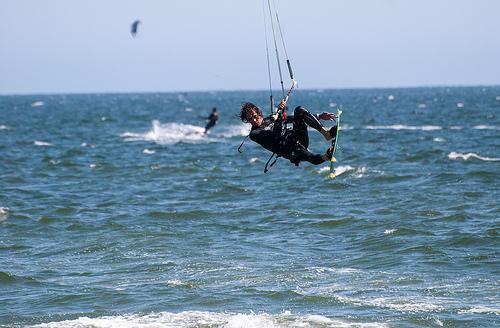How many people are there?
Give a very brief answer. 2. 